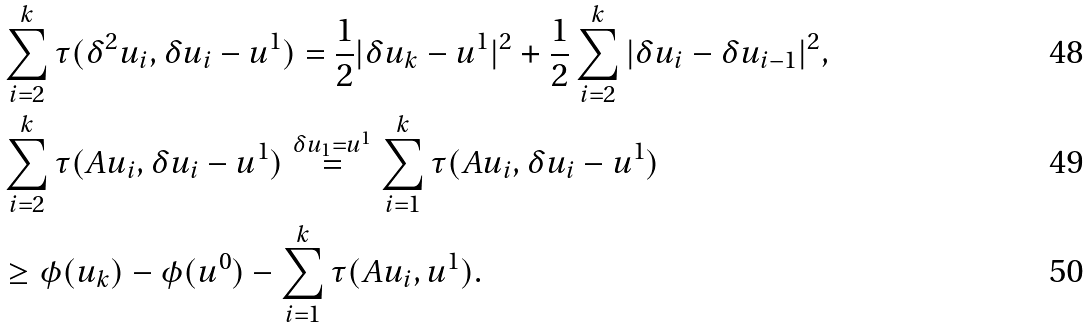<formula> <loc_0><loc_0><loc_500><loc_500>& \sum _ { i = 2 } ^ { k } \tau ( \delta ^ { 2 } u _ { i } , \delta u _ { i } - u ^ { 1 } ) = \frac { 1 } { 2 } | \delta u _ { k } - u ^ { 1 } | ^ { 2 } + \frac { 1 } { 2 } \sum _ { i = 2 } ^ { k } | \delta u _ { i } - \delta u _ { i - 1 } | ^ { 2 } , \\ & \sum _ { i = 2 } ^ { k } \tau ( A u _ { i } , \delta u _ { i } - u ^ { 1 } ) \stackrel { \delta u _ { 1 } = u ^ { 1 } } { = } \sum _ { i = 1 } ^ { k } \tau ( A u _ { i } , \delta u _ { i } - u ^ { 1 } ) \\ & \geq \phi ( u _ { k } ) - \phi ( u ^ { 0 } ) - \sum _ { i = 1 } ^ { k } \tau ( A u _ { i } , u ^ { 1 } ) .</formula> 